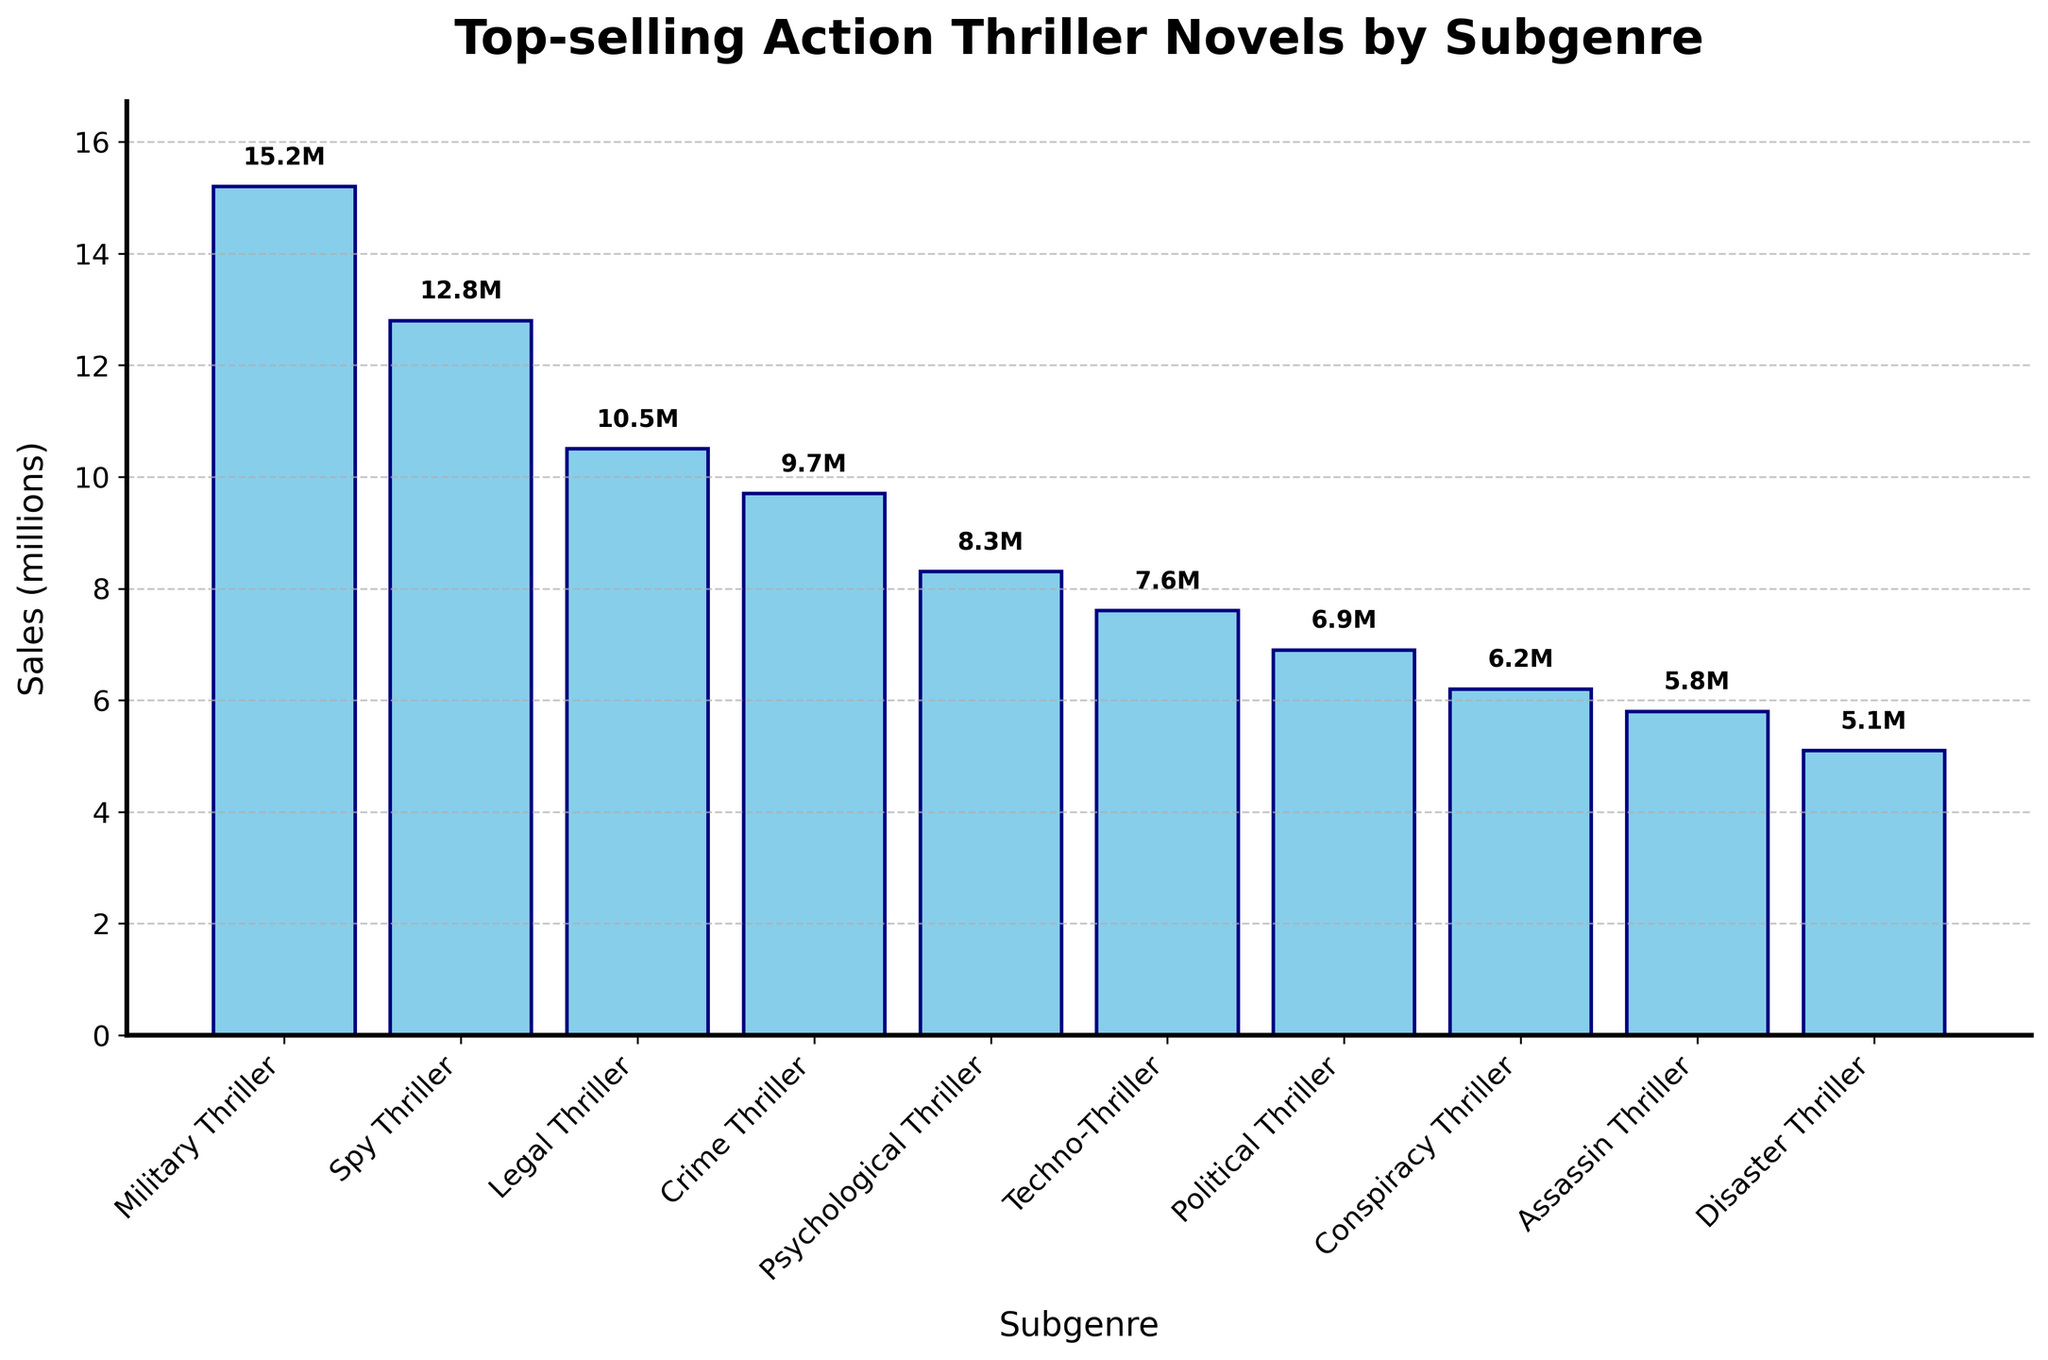Which subgenre has the highest sales? The highest bar depicts the subgenre with the highest sales, which is labeled "Military Thriller" with 15.2 million sales.
Answer: Military Thriller What is the difference in sales between the "Military Thriller" and "Techno-Thriller"? The bar for "Military Thriller" shows 15.2 million sales, and the bar for "Techno-Thriller" shows 7.6 million sales. Subtracting these gives 15.2 - 7.6 = 7.6 million.
Answer: 7.6 million Which two subgenres together have combined sales just over 21 million? Looking at the bars, summing "Spy Thriller" (12.8 million) and "Legal Thriller" (10.5 million) gives 12.8 + 10.5 = 23.3 million. Summing "Legal Thriller" (10.5 million) and "Crime Thriller" (9.7 million) gives 10.5 + 9.7 = 20.2 million.
Answer: Legal Thriller and Crime Thriller Among "Political Thriller," "Conspiracy Thriller," and "Assassin Thriller," which one has the lowest sales? Comparing the heights of the bars for these subgenres, "Conspiracy Thriller" has the lowest sales with 6.2 million.
Answer: Conspiracy Thriller What is the total sales of the subgenres with sales above 10 million? The subgenres are "Military Thriller" (15.2 million), "Spy Thriller" (12.8 million), and "Legal Thriller" (10.5 million). Summing these, we get 15.2 + 12.8 + 10.5 = 38.5 million.
Answer: 38.5 million Do "Crime Thriller" and "Psychological Thriller" together have more or fewer sales than "Military Thriller"? "Crime Thriller" (9.7 million) + "Psychological Thriller" (8.3 million) equals 9.7 + 8.3 = 18.0 million. "Military Thriller" alone has 15.2 million, so together they have more.
Answer: More Which subgenre has sales closest to the average sales of all subgenres? Calculate the average sales: (15.2 + 12.8 + 10.5 + 9.7 + 8.3 + 7.6 + 6.9 + 6.2 + 5.8 + 5.1)/10 = 88.1/10 = 8.81 million. "Psychological Thriller" with 8.3 million is closest.
Answer: Psychological Thriller How many subgenres have sales greater than "Psychological Thriller"? "Psychological Thriller" has 8.3 million sales. The subgenres with greater sales are "Military Thriller," "Spy Thriller," "Legal Thriller," and "Crime Thriller," totaling 4 subgenres.
Answer: 4 Which subgenres have sales differences of less than 1 million with their neighboring subgenres? The bars for "Assassin Thriller" (5.8 million) and "Disaster Thriller" (5.1 million) differ by less than 1 million.
Answer: Assassin Thriller and Disaster Thriller 